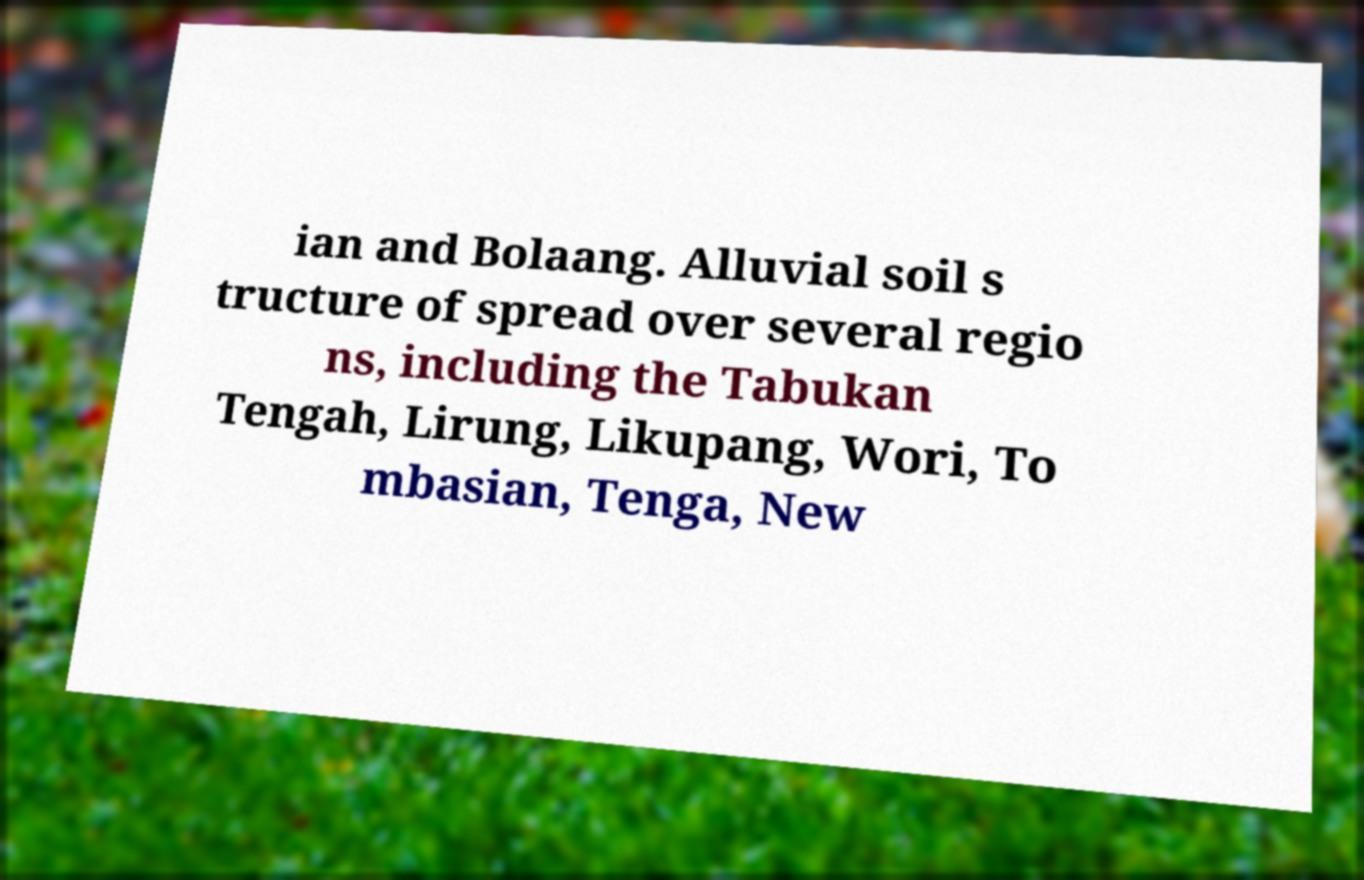There's text embedded in this image that I need extracted. Can you transcribe it verbatim? ian and Bolaang. Alluvial soil s tructure of spread over several regio ns, including the Tabukan Tengah, Lirung, Likupang, Wori, To mbasian, Tenga, New 